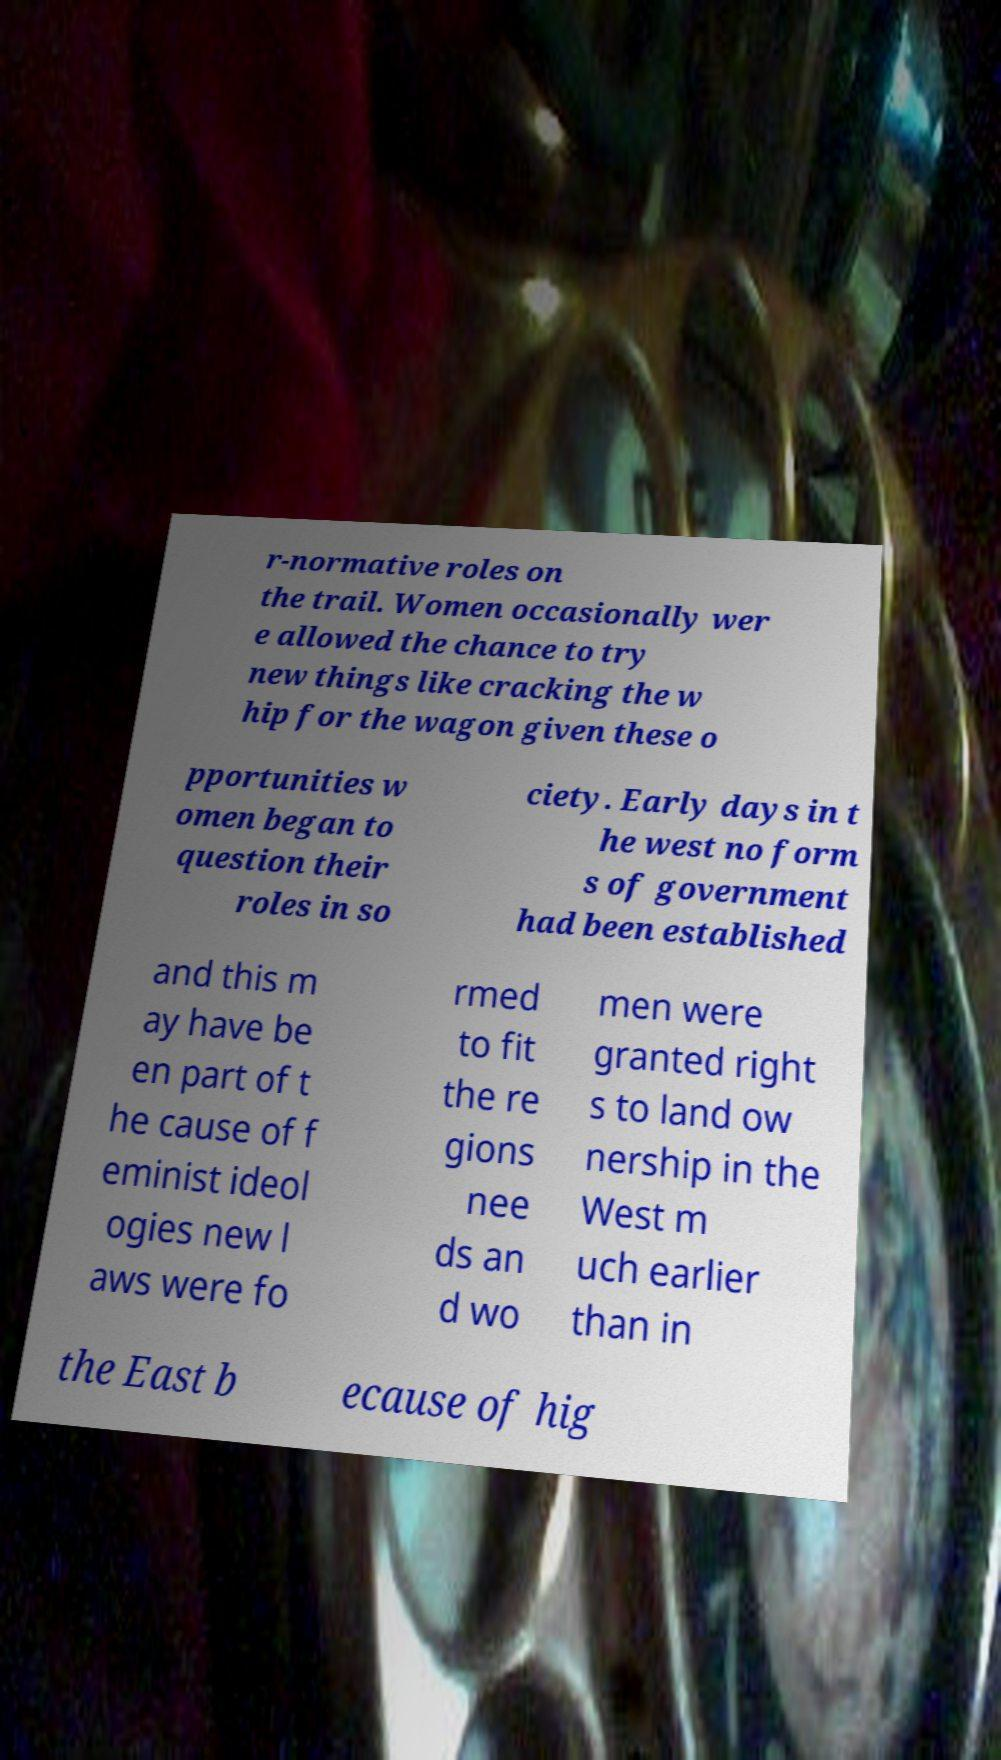What messages or text are displayed in this image? I need them in a readable, typed format. r-normative roles on the trail. Women occasionally wer e allowed the chance to try new things like cracking the w hip for the wagon given these o pportunities w omen began to question their roles in so ciety. Early days in t he west no form s of government had been established and this m ay have be en part of t he cause of f eminist ideol ogies new l aws were fo rmed to fit the re gions nee ds an d wo men were granted right s to land ow nership in the West m uch earlier than in the East b ecause of hig 